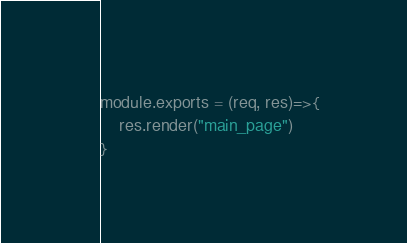<code> <loc_0><loc_0><loc_500><loc_500><_JavaScript_>module.exports = (req, res)=>{
    res.render("main_page")
}</code> 